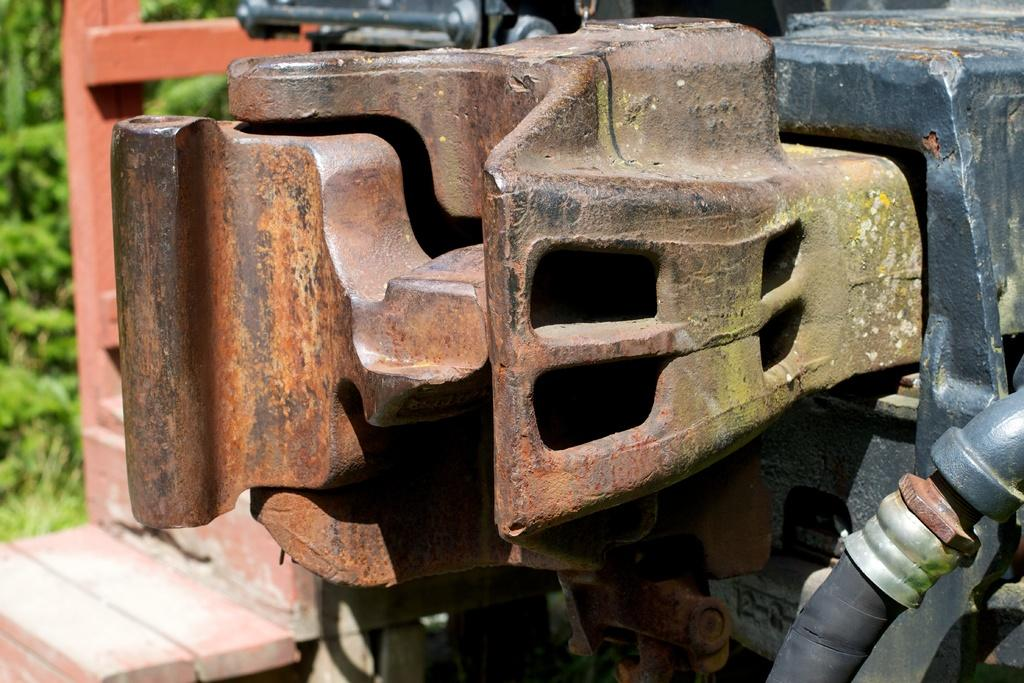What is located in the foreground of the image? There is an equipment and a pipe in the foreground of the image. Can you describe the equipment in the foreground? Unfortunately, the specific details of the equipment cannot be determined from the provided facts. What can be seen in the background of the image? There appears to be greenery in the background of the image. What type of mark can be seen on the sheet in the image? There is no sheet or mark present in the image; it only features an equipment, a pipe, and greenery in the background. 